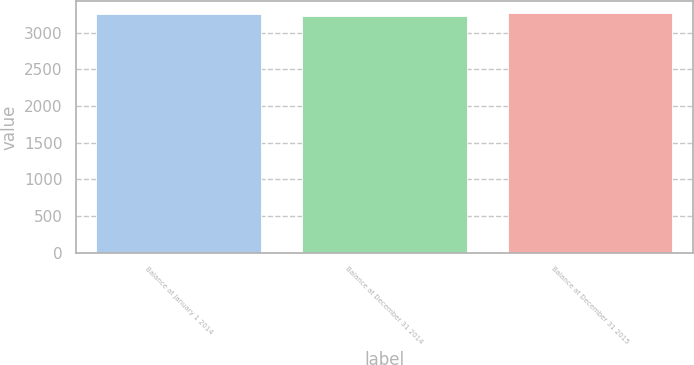<chart> <loc_0><loc_0><loc_500><loc_500><bar_chart><fcel>Balance at January 1 2014<fcel>Balance at December 31 2014<fcel>Balance at December 31 2015<nl><fcel>3253<fcel>3231<fcel>3265<nl></chart> 